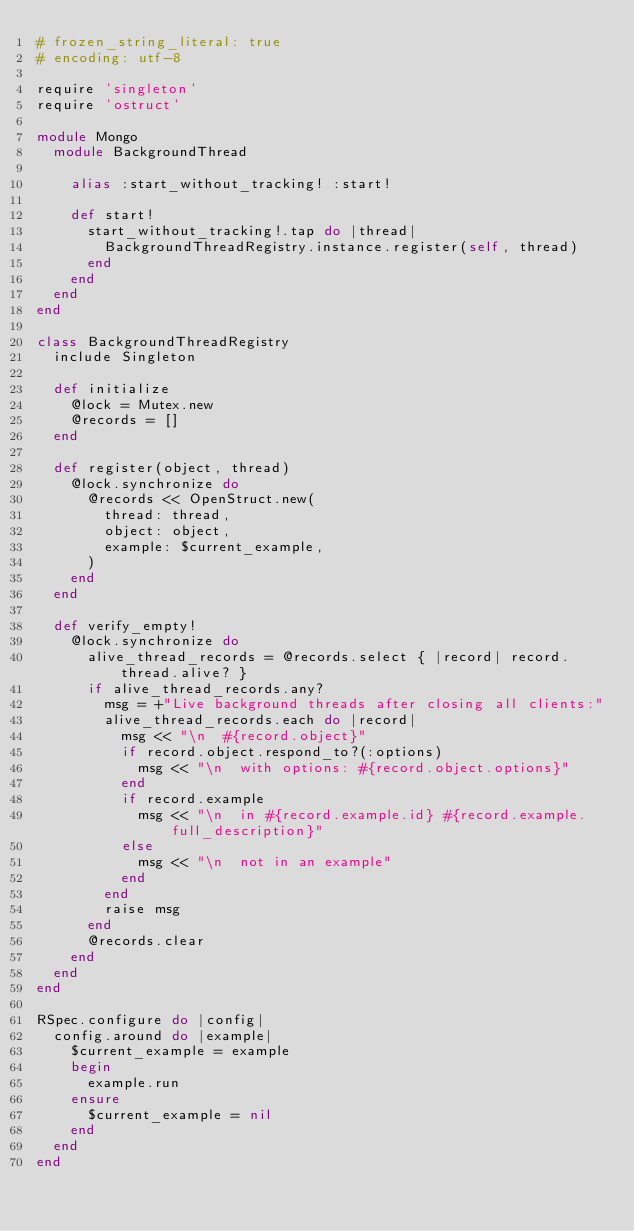Convert code to text. <code><loc_0><loc_0><loc_500><loc_500><_Ruby_># frozen_string_literal: true
# encoding: utf-8

require 'singleton'
require 'ostruct'

module Mongo
  module BackgroundThread

    alias :start_without_tracking! :start!

    def start!
      start_without_tracking!.tap do |thread|
        BackgroundThreadRegistry.instance.register(self, thread)
      end
    end
  end
end

class BackgroundThreadRegistry
  include Singleton

  def initialize
    @lock = Mutex.new
    @records = []
  end

  def register(object, thread)
    @lock.synchronize do
      @records << OpenStruct.new(
        thread: thread,
        object: object,
        example: $current_example,
      )
    end
  end

  def verify_empty!
    @lock.synchronize do
      alive_thread_records = @records.select { |record| record.thread.alive? }
      if alive_thread_records.any?
        msg = +"Live background threads after closing all clients:"
        alive_thread_records.each do |record|
          msg << "\n  #{record.object}"
          if record.object.respond_to?(:options)
            msg << "\n  with options: #{record.object.options}"
          end
          if record.example
            msg << "\n  in #{record.example.id} #{record.example.full_description}"
          else
            msg << "\n  not in an example"
          end
        end
        raise msg
      end
      @records.clear
    end
  end
end

RSpec.configure do |config|
  config.around do |example|
    $current_example = example
    begin
      example.run
    ensure
      $current_example = nil
    end
  end
end
</code> 